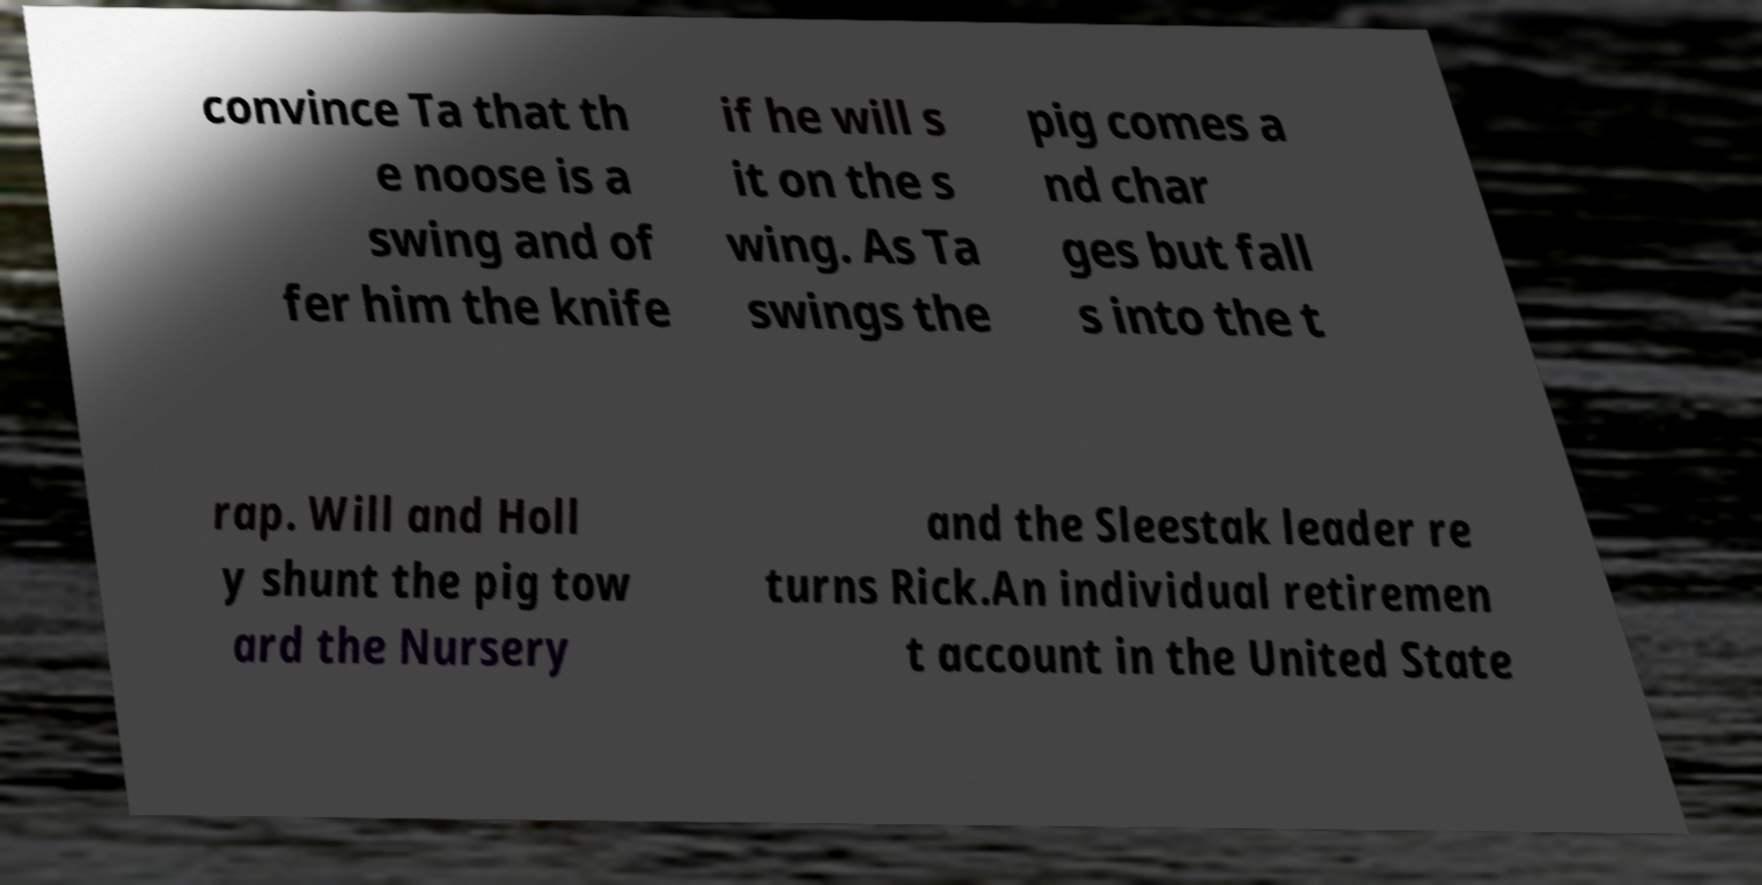Could you extract and type out the text from this image? convince Ta that th e noose is a swing and of fer him the knife if he will s it on the s wing. As Ta swings the pig comes a nd char ges but fall s into the t rap. Will and Holl y shunt the pig tow ard the Nursery and the Sleestak leader re turns Rick.An individual retiremen t account in the United State 